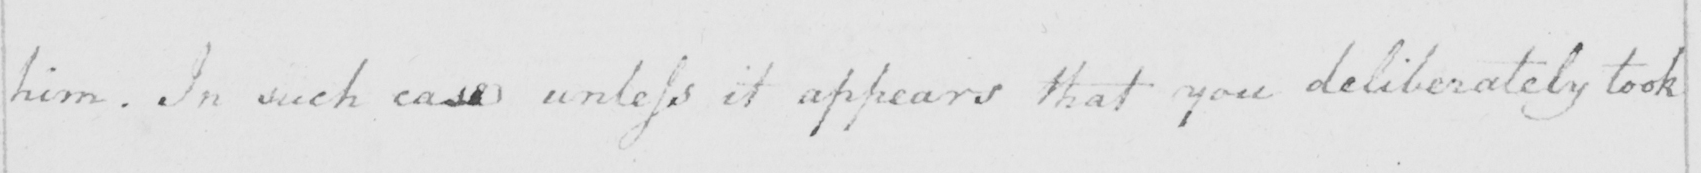Transcribe the text shown in this historical manuscript line. him. In such case unless it appears that you deliberately took 